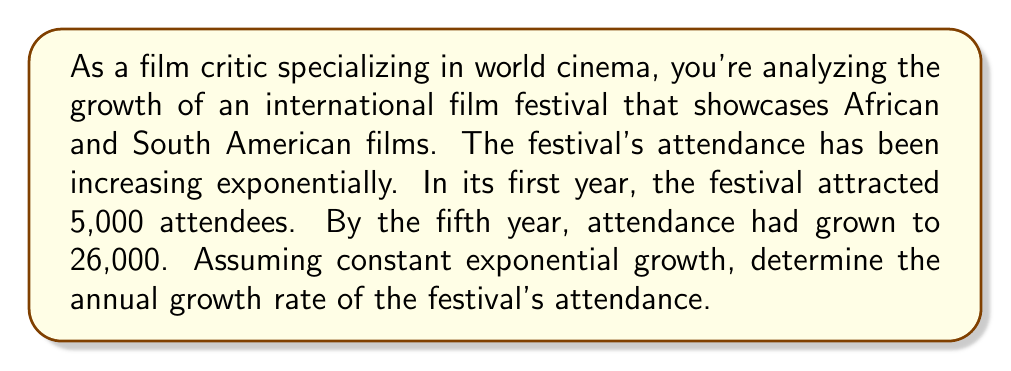Solve this math problem. To solve this problem, we'll use the exponential growth formula:

$$A = P(1 + r)^t$$

Where:
$A$ = Final amount
$P$ = Initial amount
$r$ = Annual growth rate (in decimal form)
$t$ = Time (in years)

Given:
$P = 5,000$ (initial attendance)
$A = 26,000$ (attendance after 5 years)
$t = 5$ (years)

Let's substitute these values into the formula:

$$26,000 = 5,000(1 + r)^5$$

Now, we'll solve for $r$:

1) Divide both sides by 5,000:
   $$\frac{26,000}{5,000} = (1 + r)^5$$
   $$5.2 = (1 + r)^5$$

2) Take the fifth root of both sides:
   $$\sqrt[5]{5.2} = 1 + r$$

3) Subtract 1 from both sides:
   $$\sqrt[5]{5.2} - 1 = r$$

4) Calculate the value:
   $$r \approx 1.3895 - 1 = 0.3895$$

5) Convert to a percentage:
   $$r \approx 0.3895 \times 100\% = 38.95\%$$

Therefore, the annual growth rate of the festival's attendance is approximately 38.95%.
Answer: The annual growth rate of the film festival's attendance is approximately 38.95%. 